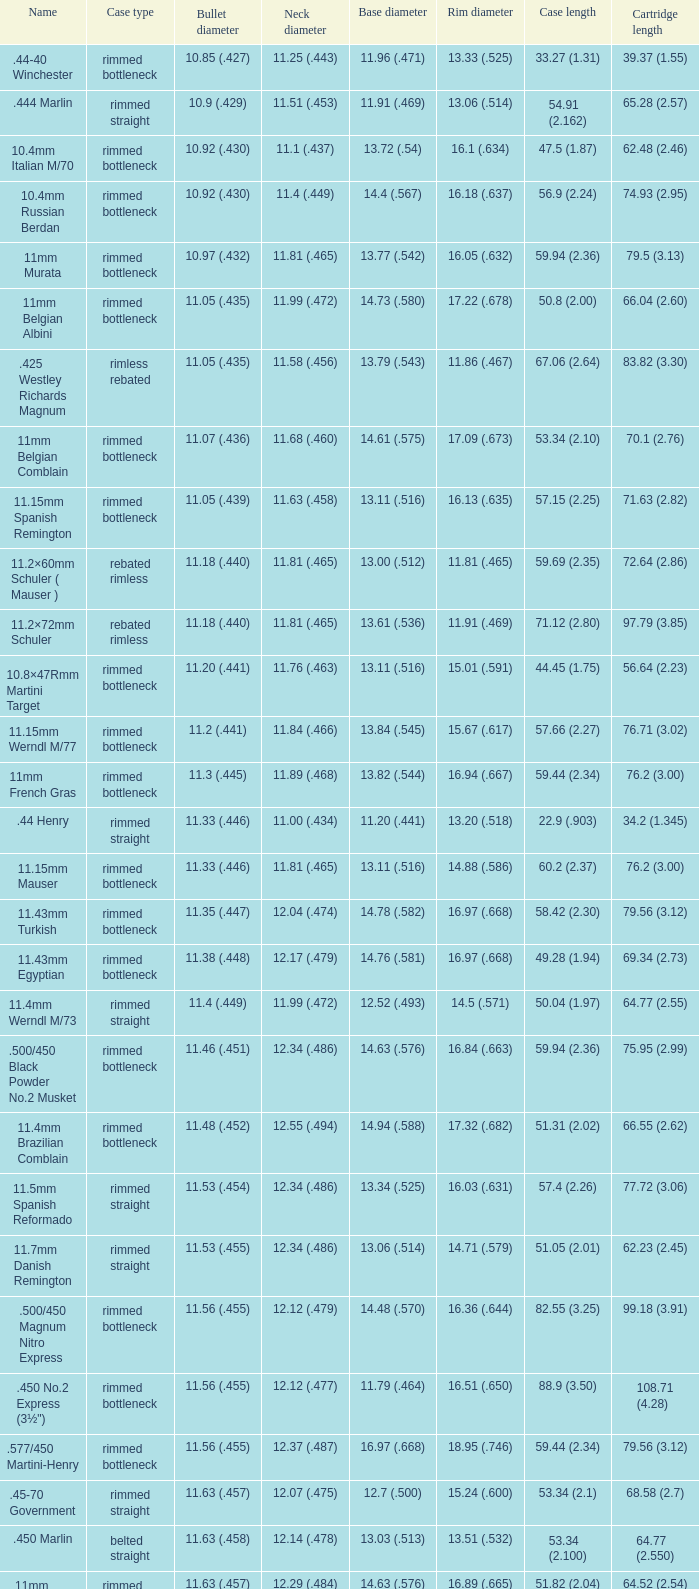Could you parse the entire table? {'header': ['Name', 'Case type', 'Bullet diameter', 'Neck diameter', 'Base diameter', 'Rim diameter', 'Case length', 'Cartridge length'], 'rows': [['.44-40 Winchester', 'rimmed bottleneck', '10.85 (.427)', '11.25 (.443)', '11.96 (.471)', '13.33 (.525)', '33.27 (1.31)', '39.37 (1.55)'], ['.444 Marlin', 'rimmed straight', '10.9 (.429)', '11.51 (.453)', '11.91 (.469)', '13.06 (.514)', '54.91 (2.162)', '65.28 (2.57)'], ['10.4mm Italian M/70', 'rimmed bottleneck', '10.92 (.430)', '11.1 (.437)', '13.72 (.54)', '16.1 (.634)', '47.5 (1.87)', '62.48 (2.46)'], ['10.4mm Russian Berdan', 'rimmed bottleneck', '10.92 (.430)', '11.4 (.449)', '14.4 (.567)', '16.18 (.637)', '56.9 (2.24)', '74.93 (2.95)'], ['11mm Murata', 'rimmed bottleneck', '10.97 (.432)', '11.81 (.465)', '13.77 (.542)', '16.05 (.632)', '59.94 (2.36)', '79.5 (3.13)'], ['11mm Belgian Albini', 'rimmed bottleneck', '11.05 (.435)', '11.99 (.472)', '14.73 (.580)', '17.22 (.678)', '50.8 (2.00)', '66.04 (2.60)'], ['.425 Westley Richards Magnum', 'rimless rebated', '11.05 (.435)', '11.58 (.456)', '13.79 (.543)', '11.86 (.467)', '67.06 (2.64)', '83.82 (3.30)'], ['11mm Belgian Comblain', 'rimmed bottleneck', '11.07 (.436)', '11.68 (.460)', '14.61 (.575)', '17.09 (.673)', '53.34 (2.10)', '70.1 (2.76)'], ['11.15mm Spanish Remington', 'rimmed bottleneck', '11.05 (.439)', '11.63 (.458)', '13.11 (.516)', '16.13 (.635)', '57.15 (2.25)', '71.63 (2.82)'], ['11.2×60mm Schuler ( Mauser )', 'rebated rimless', '11.18 (.440)', '11.81 (.465)', '13.00 (.512)', '11.81 (.465)', '59.69 (2.35)', '72.64 (2.86)'], ['11.2×72mm Schuler', 'rebated rimless', '11.18 (.440)', '11.81 (.465)', '13.61 (.536)', '11.91 (.469)', '71.12 (2.80)', '97.79 (3.85)'], ['10.8×47Rmm Martini Target', 'rimmed bottleneck', '11.20 (.441)', '11.76 (.463)', '13.11 (.516)', '15.01 (.591)', '44.45 (1.75)', '56.64 (2.23)'], ['11.15mm Werndl M/77', 'rimmed bottleneck', '11.2 (.441)', '11.84 (.466)', '13.84 (.545)', '15.67 (.617)', '57.66 (2.27)', '76.71 (3.02)'], ['11mm French Gras', 'rimmed bottleneck', '11.3 (.445)', '11.89 (.468)', '13.82 (.544)', '16.94 (.667)', '59.44 (2.34)', '76.2 (3.00)'], ['.44 Henry', 'rimmed straight', '11.33 (.446)', '11.00 (.434)', '11.20 (.441)', '13.20 (.518)', '22.9 (.903)', '34.2 (1.345)'], ['11.15mm Mauser', 'rimmed bottleneck', '11.33 (.446)', '11.81 (.465)', '13.11 (.516)', '14.88 (.586)', '60.2 (2.37)', '76.2 (3.00)'], ['11.43mm Turkish', 'rimmed bottleneck', '11.35 (.447)', '12.04 (.474)', '14.78 (.582)', '16.97 (.668)', '58.42 (2.30)', '79.56 (3.12)'], ['11.43mm Egyptian', 'rimmed bottleneck', '11.38 (.448)', '12.17 (.479)', '14.76 (.581)', '16.97 (.668)', '49.28 (1.94)', '69.34 (2.73)'], ['11.4mm Werndl M/73', 'rimmed straight', '11.4 (.449)', '11.99 (.472)', '12.52 (.493)', '14.5 (.571)', '50.04 (1.97)', '64.77 (2.55)'], ['.500/450 Black Powder No.2 Musket', 'rimmed bottleneck', '11.46 (.451)', '12.34 (.486)', '14.63 (.576)', '16.84 (.663)', '59.94 (2.36)', '75.95 (2.99)'], ['11.4mm Brazilian Comblain', 'rimmed bottleneck', '11.48 (.452)', '12.55 (.494)', '14.94 (.588)', '17.32 (.682)', '51.31 (2.02)', '66.55 (2.62)'], ['11.5mm Spanish Reformado', 'rimmed straight', '11.53 (.454)', '12.34 (.486)', '13.34 (.525)', '16.03 (.631)', '57.4 (2.26)', '77.72 (3.06)'], ['11.7mm Danish Remington', 'rimmed straight', '11.53 (.455)', '12.34 (.486)', '13.06 (.514)', '14.71 (.579)', '51.05 (2.01)', '62.23 (2.45)'], ['.500/450 Magnum Nitro Express', 'rimmed bottleneck', '11.56 (.455)', '12.12 (.479)', '14.48 (.570)', '16.36 (.644)', '82.55 (3.25)', '99.18 (3.91)'], ['.450 No.2 Express (3½")', 'rimmed bottleneck', '11.56 (.455)', '12.12 (.477)', '11.79 (.464)', '16.51 (.650)', '88.9 (3.50)', '108.71 (4.28)'], ['.577/450 Martini-Henry', 'rimmed bottleneck', '11.56 (.455)', '12.37 (.487)', '16.97 (.668)', '18.95 (.746)', '59.44 (2.34)', '79.56 (3.12)'], ['.45-70 Government', 'rimmed straight', '11.63 (.457)', '12.07 (.475)', '12.7 (.500)', '15.24 (.600)', '53.34 (2.1)', '68.58 (2.7)'], ['.450 Marlin', 'belted straight', '11.63 (.458)', '12.14 (.478)', '13.03 (.513)', '13.51 (.532)', '53.34 (2.100)', '64.77 (2.550)'], ['11mm Beaumont M/71/78', 'rimmed bottleneck', '11.63 (.457)', '12.29 (.484)', '14.63 (.576)', '16.89 (.665)', '51.82 (2.04)', '64.52 (2.54)'], ['.450 Nitro Express (3¼")', 'rimmed straight', '11.63 (.458)', '12.12 (.479)', '13.92 (.548)', '15.9 (.626)', '82.55 (3.25)', '97.79 (3.85)'], ['.458 Winchester Magnum', 'belted straight', '11.63 (.458)', '12.14 (.478)', '13.03 (.513)', '13.51 (.532)', '63.5 (2.5)', '82.55 (3.350)'], ['.460 Weatherby Magnum', 'belted bottleneck', '11.63 (.458)', '12.32 (.485)', '14.80 (.583)', '13.54 (.533)', '74 (2.91)', '95.25 (3.75)'], ['.500/450 No.1 Express', 'rimmed bottleneck', '11.63 (.458)', '12.32 (.485)', '14.66 (.577)', '16.76 (.660)', '69.85 (2.75)', '82.55 (3.25)'], ['.450 Rigby Rimless', 'rimless bottleneck', '11.63 (.458)', '12.38 (.487)', '14.66 (.577)', '14.99 (.590)', '73.50 (2.89)', '95.00 (3.74)'], ['11.3mm Beaumont M/71', 'rimmed bottleneck', '11.63 (.464)', '12.34 (.486)', '14.76 (.581)', '16.92 (.666)', '50.04 (1.97)', '63.25 (2.49)'], ['.500/465 Nitro Express', 'rimmed bottleneck', '11.84 (.466)', '12.39 (.488)', '14.55 (.573)', '16.51 (.650)', '82.3 (3.24)', '98.04 (3.89)']]} Which Bullet diameter has a Neck diameter of 12.17 (.479)? 11.38 (.448). 